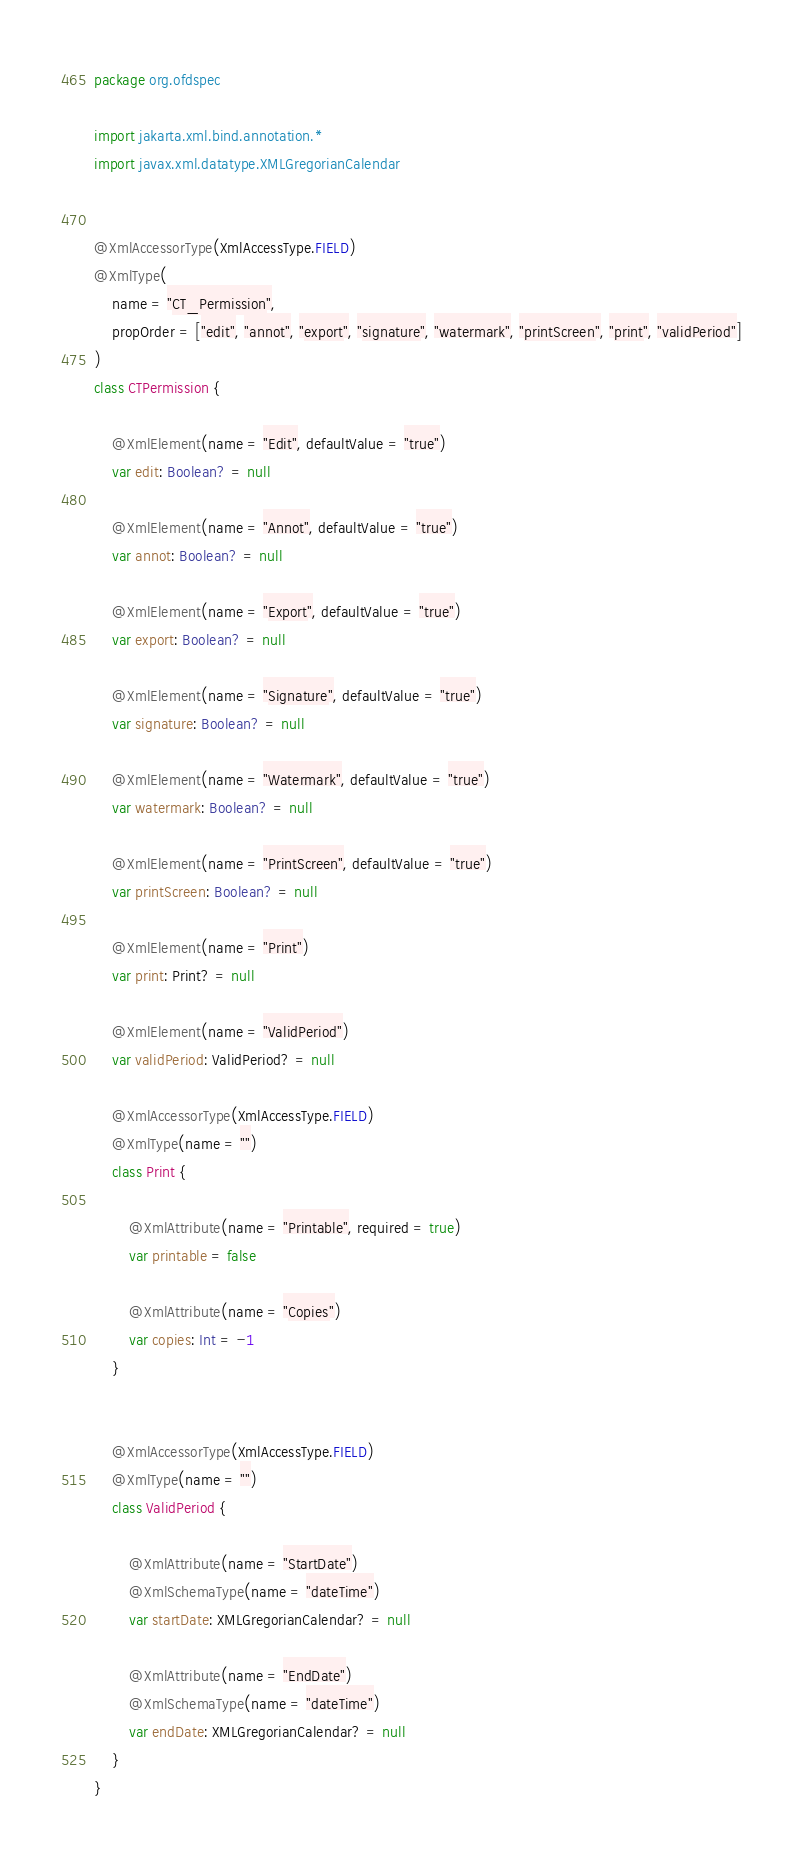Convert code to text. <code><loc_0><loc_0><loc_500><loc_500><_Kotlin_>package org.ofdspec

import jakarta.xml.bind.annotation.*
import javax.xml.datatype.XMLGregorianCalendar


@XmlAccessorType(XmlAccessType.FIELD)
@XmlType(
    name = "CT_Permission",
    propOrder = ["edit", "annot", "export", "signature", "watermark", "printScreen", "print", "validPeriod"]
)
class CTPermission {

    @XmlElement(name = "Edit", defaultValue = "true")
    var edit: Boolean? = null

    @XmlElement(name = "Annot", defaultValue = "true")
    var annot: Boolean? = null

    @XmlElement(name = "Export", defaultValue = "true")
    var export: Boolean? = null

    @XmlElement(name = "Signature", defaultValue = "true")
    var signature: Boolean? = null

    @XmlElement(name = "Watermark", defaultValue = "true")
    var watermark: Boolean? = null

    @XmlElement(name = "PrintScreen", defaultValue = "true")
    var printScreen: Boolean? = null

    @XmlElement(name = "Print")
    var print: Print? = null

    @XmlElement(name = "ValidPeriod")
    var validPeriod: ValidPeriod? = null

    @XmlAccessorType(XmlAccessType.FIELD)
    @XmlType(name = "")
    class Print {

        @XmlAttribute(name = "Printable", required = true)
        var printable = false

        @XmlAttribute(name = "Copies")
        var copies: Int = -1
    }


    @XmlAccessorType(XmlAccessType.FIELD)
    @XmlType(name = "")
    class ValidPeriod {

        @XmlAttribute(name = "StartDate")
        @XmlSchemaType(name = "dateTime")
        var startDate: XMLGregorianCalendar? = null

        @XmlAttribute(name = "EndDate")
        @XmlSchemaType(name = "dateTime")
        var endDate: XMLGregorianCalendar? = null
    }
}</code> 